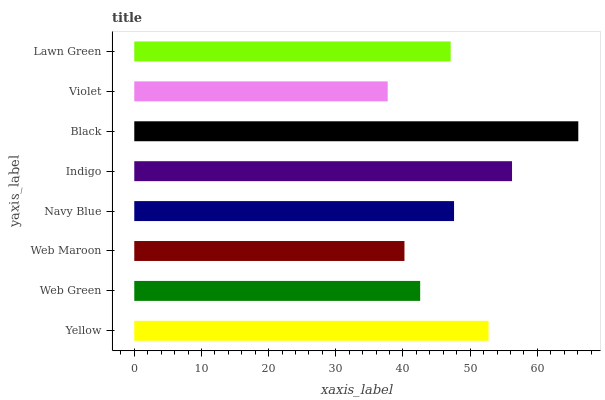Is Violet the minimum?
Answer yes or no. Yes. Is Black the maximum?
Answer yes or no. Yes. Is Web Green the minimum?
Answer yes or no. No. Is Web Green the maximum?
Answer yes or no. No. Is Yellow greater than Web Green?
Answer yes or no. Yes. Is Web Green less than Yellow?
Answer yes or no. Yes. Is Web Green greater than Yellow?
Answer yes or no. No. Is Yellow less than Web Green?
Answer yes or no. No. Is Navy Blue the high median?
Answer yes or no. Yes. Is Lawn Green the low median?
Answer yes or no. Yes. Is Violet the high median?
Answer yes or no. No. Is Yellow the low median?
Answer yes or no. No. 